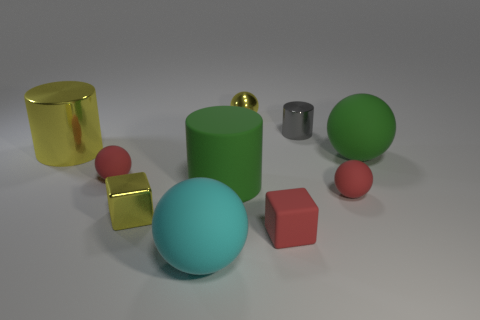Subtract all green spheres. How many spheres are left? 4 Subtract all big cyan rubber balls. How many balls are left? 4 Subtract 1 spheres. How many spheres are left? 4 Subtract all blue spheres. Subtract all purple blocks. How many spheres are left? 5 Subtract all cylinders. How many objects are left? 7 Subtract all blue rubber blocks. Subtract all small matte balls. How many objects are left? 8 Add 3 green matte cylinders. How many green matte cylinders are left? 4 Add 1 big purple cylinders. How many big purple cylinders exist? 1 Subtract 0 cyan blocks. How many objects are left? 10 